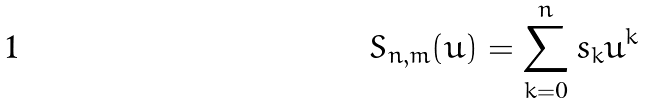<formula> <loc_0><loc_0><loc_500><loc_500>S _ { n , m } ( u ) = \sum _ { k = 0 } ^ { n } s _ { k } u ^ { k }</formula> 